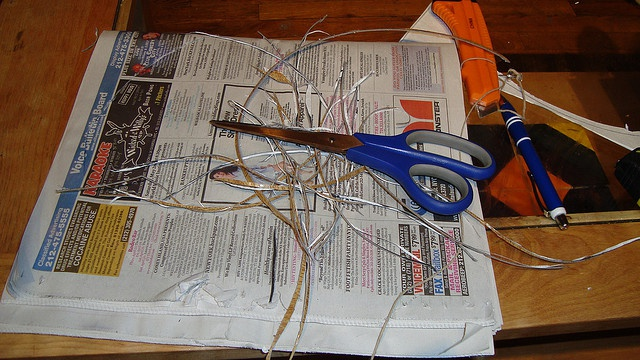Describe the objects in this image and their specific colors. I can see scissors in black, navy, gray, and maroon tones in this image. 